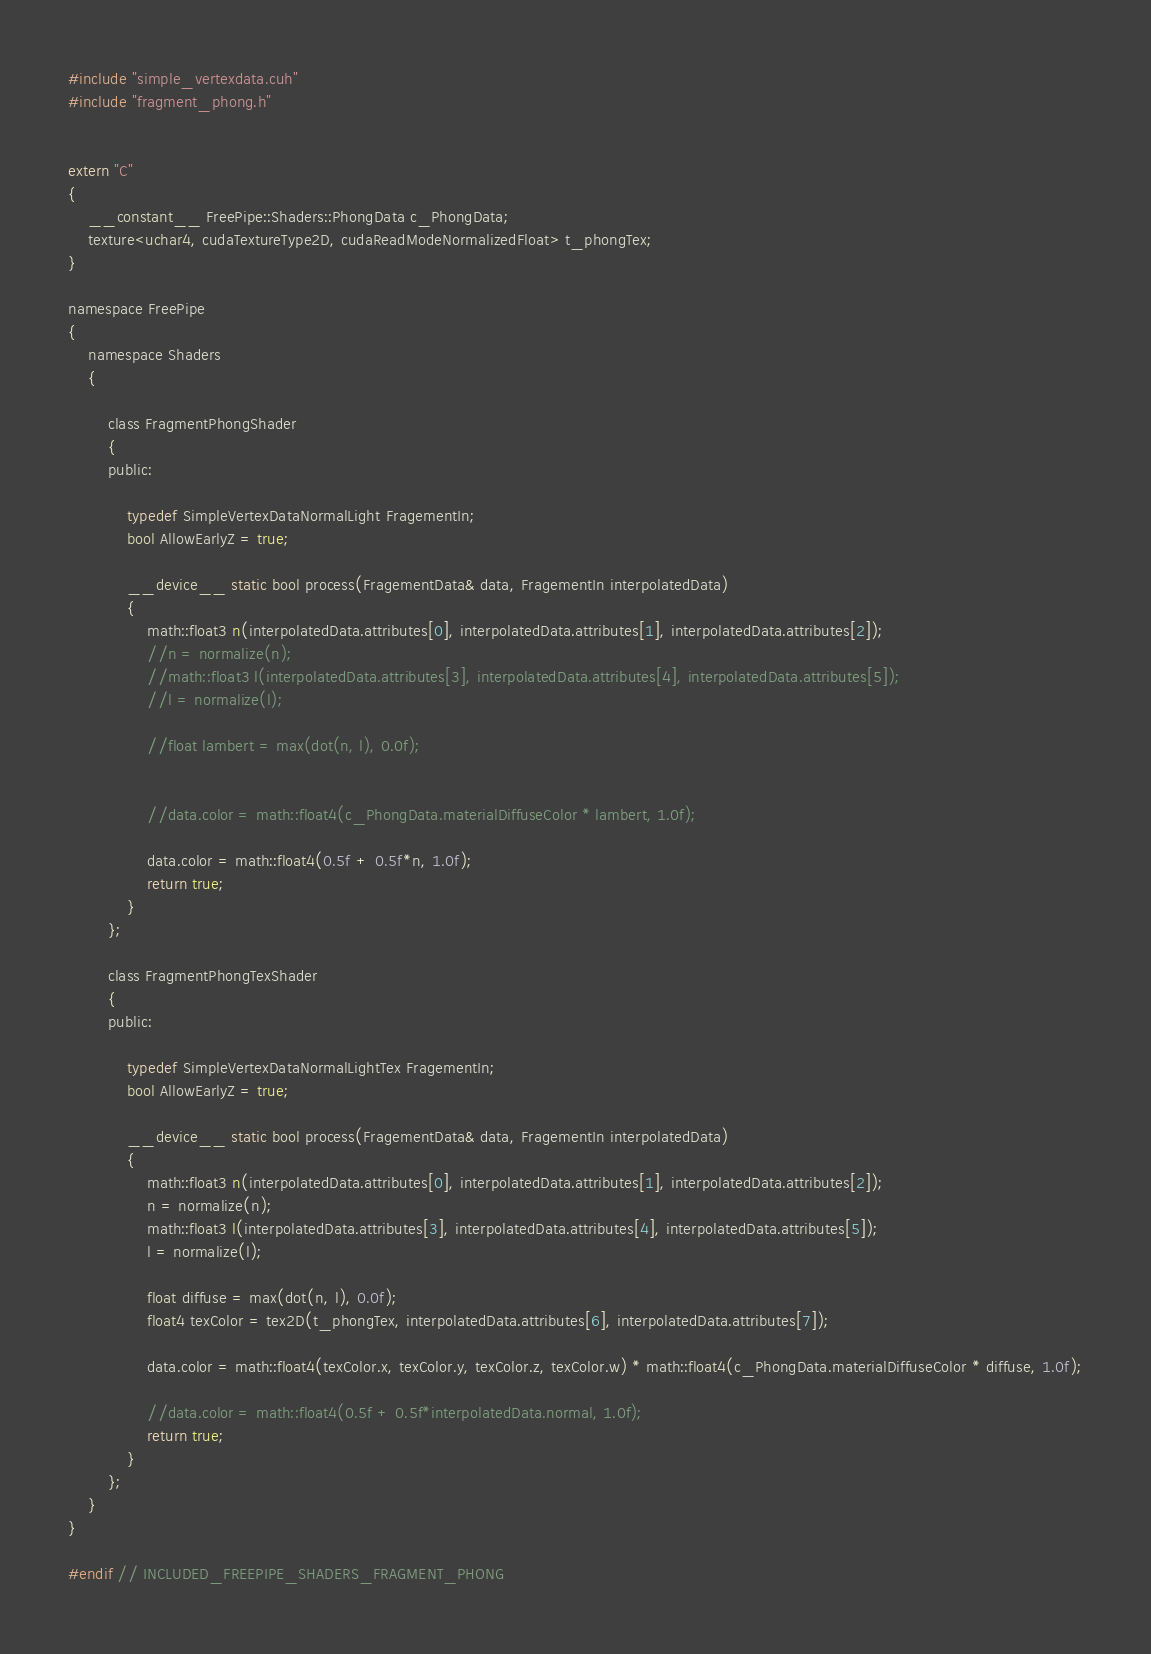Convert code to text. <code><loc_0><loc_0><loc_500><loc_500><_Cuda_>#include "simple_vertexdata.cuh"
#include "fragment_phong.h"


extern "C"
{
	__constant__ FreePipe::Shaders::PhongData c_PhongData;
	texture<uchar4, cudaTextureType2D, cudaReadModeNormalizedFloat> t_phongTex;
}

namespace FreePipe
{
	namespace Shaders
	{

		class FragmentPhongShader
		{
		public:

			typedef SimpleVertexDataNormalLight FragementIn;
			bool AllowEarlyZ = true;

			__device__ static bool process(FragementData& data, FragementIn interpolatedData)
			{
				math::float3 n(interpolatedData.attributes[0], interpolatedData.attributes[1], interpolatedData.attributes[2]);
				//n = normalize(n);
				//math::float3 l(interpolatedData.attributes[3], interpolatedData.attributes[4], interpolatedData.attributes[5]);
				//l = normalize(l);

				//float lambert = max(dot(n, l), 0.0f);


				//data.color = math::float4(c_PhongData.materialDiffuseColor * lambert, 1.0f);

				data.color = math::float4(0.5f + 0.5f*n, 1.0f);
				return true;
			}
		};

		class FragmentPhongTexShader
		{
		public:

			typedef SimpleVertexDataNormalLightTex FragementIn;
			bool AllowEarlyZ = true;

			__device__ static bool process(FragementData& data, FragementIn interpolatedData)
			{
				math::float3 n(interpolatedData.attributes[0], interpolatedData.attributes[1], interpolatedData.attributes[2]);
				n = normalize(n);
				math::float3 l(interpolatedData.attributes[3], interpolatedData.attributes[4], interpolatedData.attributes[5]);
				l = normalize(l);

				float diffuse = max(dot(n, l), 0.0f);
				float4 texColor = tex2D(t_phongTex, interpolatedData.attributes[6], interpolatedData.attributes[7]);

				data.color = math::float4(texColor.x, texColor.y, texColor.z, texColor.w) * math::float4(c_PhongData.materialDiffuseColor * diffuse, 1.0f);

				//data.color = math::float4(0.5f + 0.5f*interpolatedData.normal, 1.0f);
				return true;
			}
		};
	}
}

#endif // INCLUDED_FREEPIPE_SHADERS_FRAGMENT_PHONG
</code> 